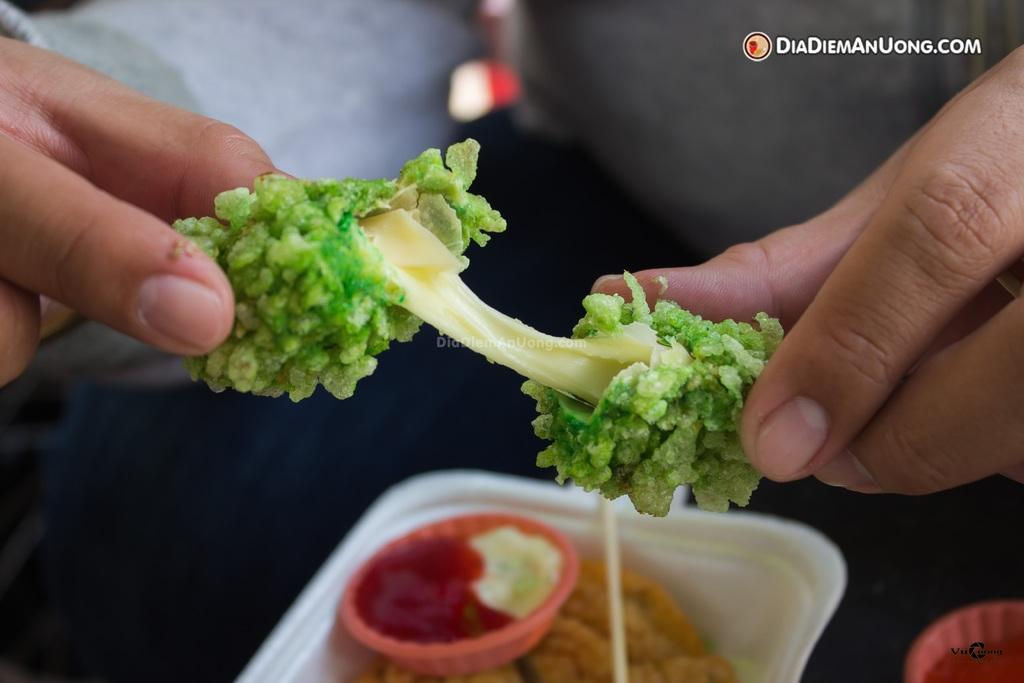Who is present in the image? There is a person in the image. What is the person holding in the image? The person is holding a food item. What can be seen inside the white box in the image? There is another food item in the white box. What type of condiments or toppings are visible in the image? There are sauces in the image. How many rabbits are present at the feast in the image? There are no rabbits or feast present in the image. What type of rice is being served at the feast in the image? There is no rice or feast present in the image. 